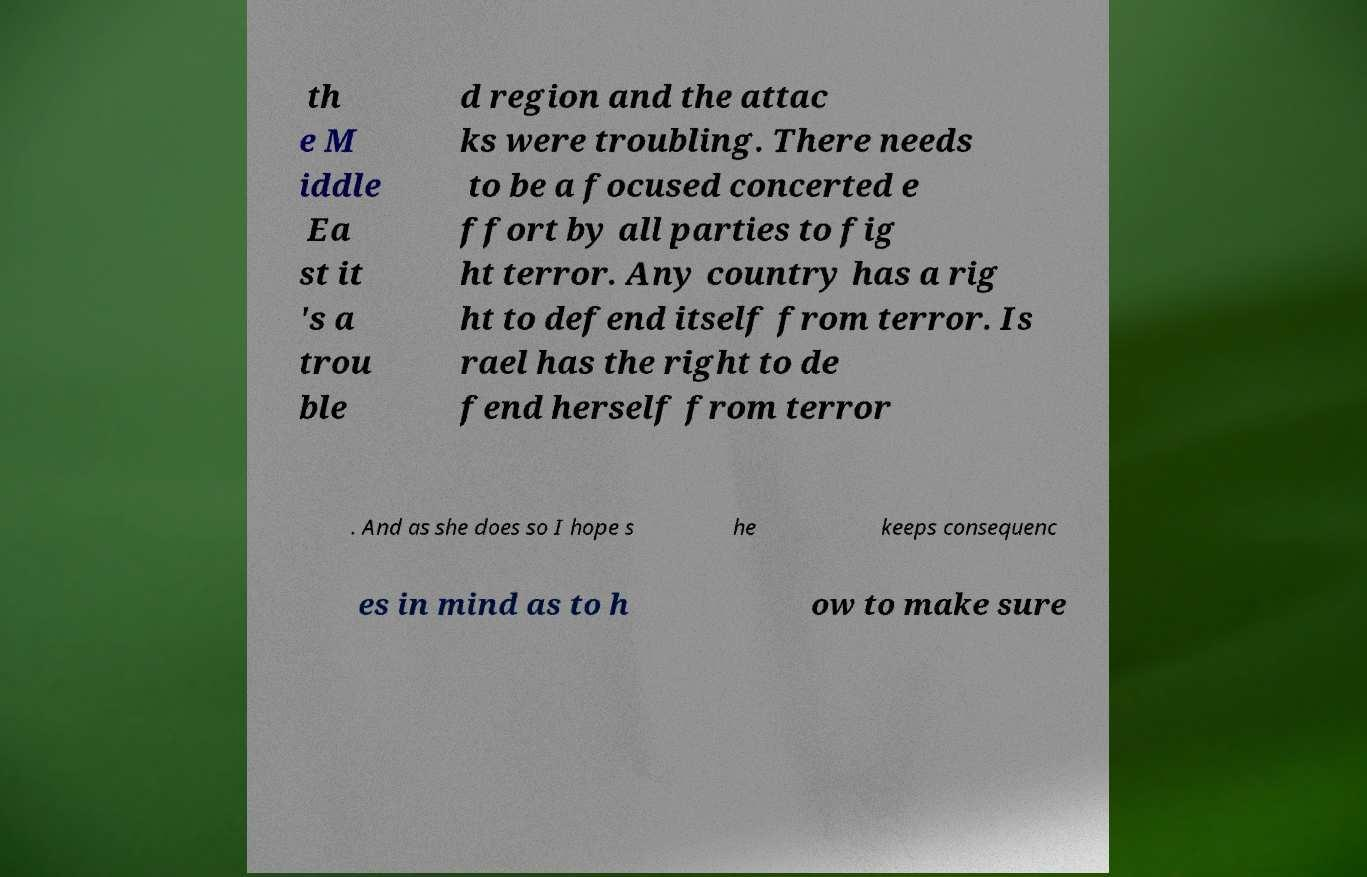Could you extract and type out the text from this image? th e M iddle Ea st it 's a trou ble d region and the attac ks were troubling. There needs to be a focused concerted e ffort by all parties to fig ht terror. Any country has a rig ht to defend itself from terror. Is rael has the right to de fend herself from terror . And as she does so I hope s he keeps consequenc es in mind as to h ow to make sure 